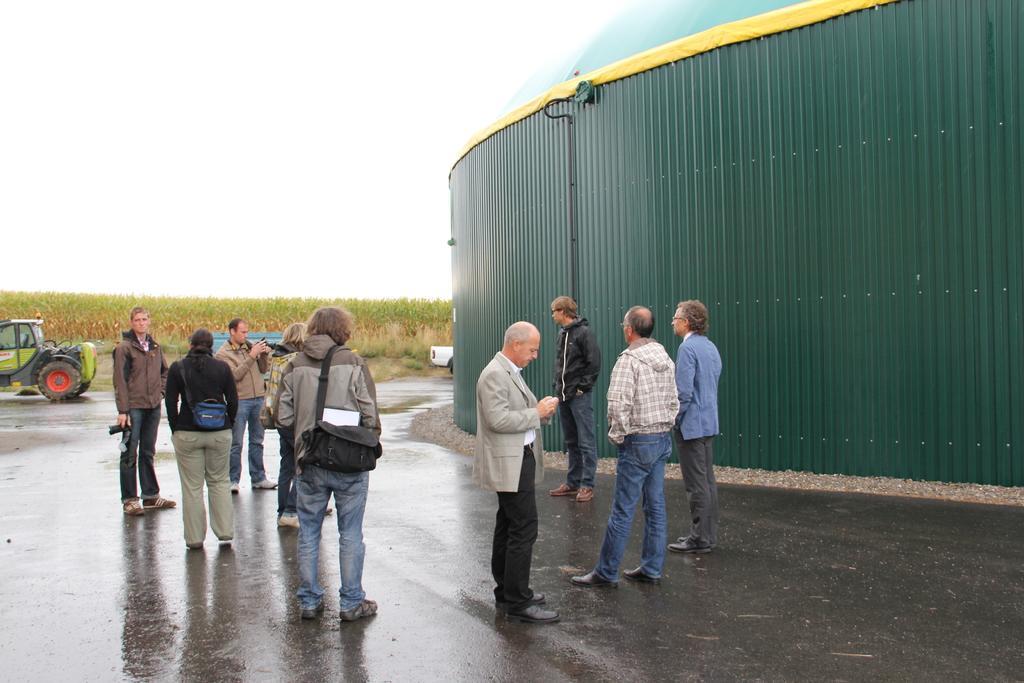How would you summarize this image in a sentence or two? In this image there are many people few of them are holding camera. Here there is a vehicle. In the background there are trees. This is a building. 